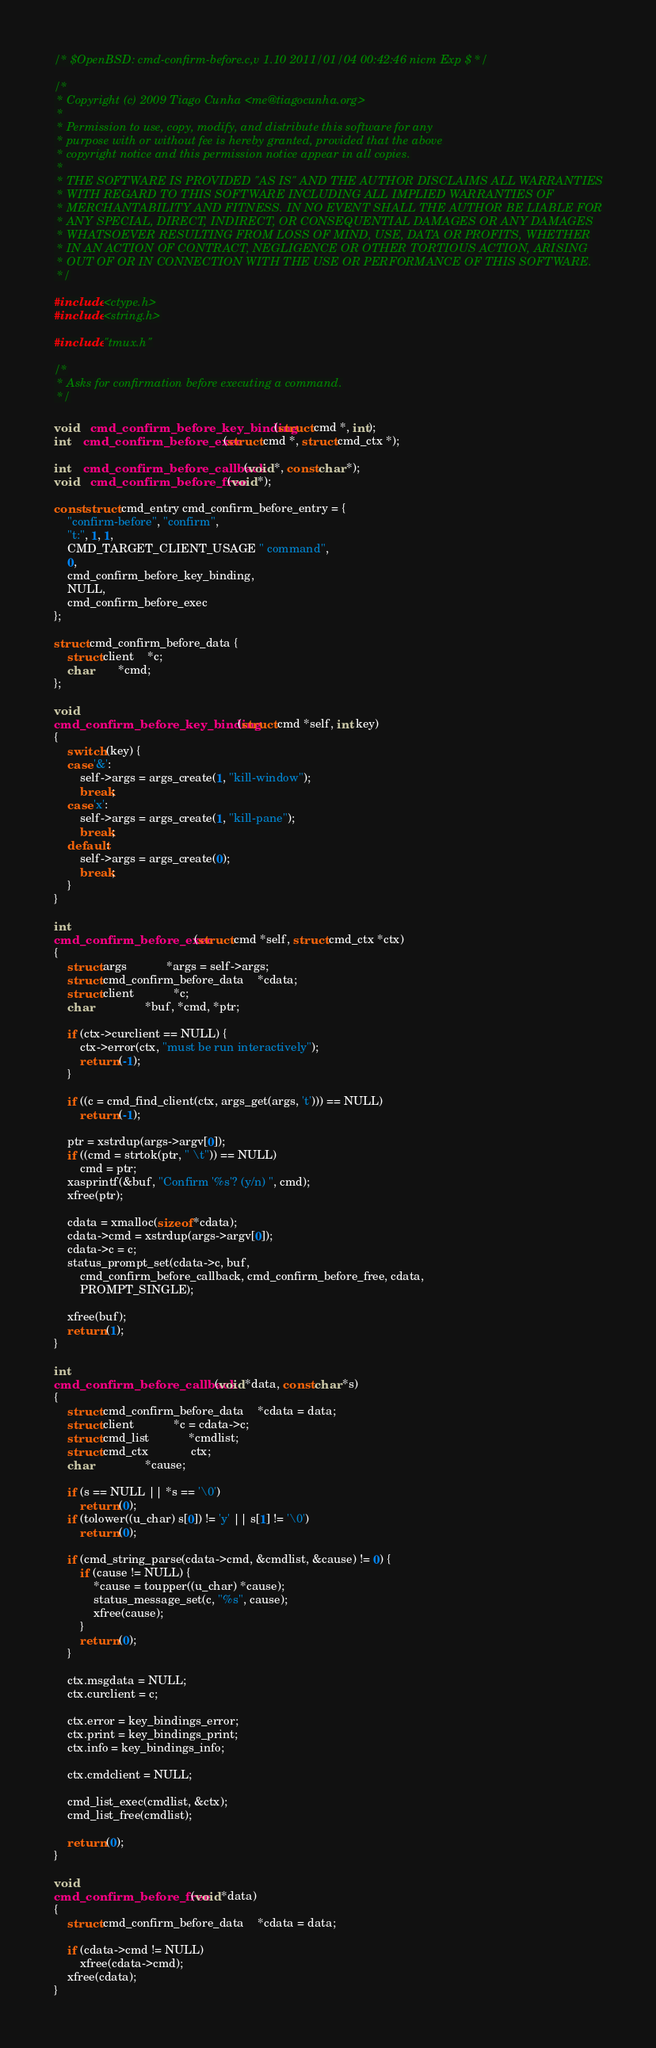Convert code to text. <code><loc_0><loc_0><loc_500><loc_500><_C_>/* $OpenBSD: cmd-confirm-before.c,v 1.10 2011/01/04 00:42:46 nicm Exp $ */

/*
 * Copyright (c) 2009 Tiago Cunha <me@tiagocunha.org>
 *
 * Permission to use, copy, modify, and distribute this software for any
 * purpose with or without fee is hereby granted, provided that the above
 * copyright notice and this permission notice appear in all copies.
 *
 * THE SOFTWARE IS PROVIDED "AS IS" AND THE AUTHOR DISCLAIMS ALL WARRANTIES
 * WITH REGARD TO THIS SOFTWARE INCLUDING ALL IMPLIED WARRANTIES OF
 * MERCHANTABILITY AND FITNESS. IN NO EVENT SHALL THE AUTHOR BE LIABLE FOR
 * ANY SPECIAL, DIRECT, INDIRECT, OR CONSEQUENTIAL DAMAGES OR ANY DAMAGES
 * WHATSOEVER RESULTING FROM LOSS OF MIND, USE, DATA OR PROFITS, WHETHER
 * IN AN ACTION OF CONTRACT, NEGLIGENCE OR OTHER TORTIOUS ACTION, ARISING
 * OUT OF OR IN CONNECTION WITH THE USE OR PERFORMANCE OF THIS SOFTWARE.
 */

#include <ctype.h>
#include <string.h>

#include "tmux.h"

/*
 * Asks for confirmation before executing a command.
 */

void	cmd_confirm_before_key_binding(struct cmd *, int);
int	cmd_confirm_before_exec(struct cmd *, struct cmd_ctx *);

int	cmd_confirm_before_callback(void *, const char *);
void	cmd_confirm_before_free(void *);

const struct cmd_entry cmd_confirm_before_entry = {
	"confirm-before", "confirm",
	"t:", 1, 1,
	CMD_TARGET_CLIENT_USAGE " command",
	0,
	cmd_confirm_before_key_binding,
	NULL,
	cmd_confirm_before_exec
};

struct cmd_confirm_before_data {
	struct client	*c;
	char		*cmd;
};

void
cmd_confirm_before_key_binding(struct cmd *self, int key)
{
	switch (key) {
	case '&':
		self->args = args_create(1, "kill-window");
		break;
	case 'x':
		self->args = args_create(1, "kill-pane");
		break;
	default:
		self->args = args_create(0);
		break;
	}
}

int
cmd_confirm_before_exec(struct cmd *self, struct cmd_ctx *ctx)
{
	struct args			*args = self->args;
	struct cmd_confirm_before_data	*cdata;
	struct client			*c;
	char				*buf, *cmd, *ptr;

	if (ctx->curclient == NULL) {
		ctx->error(ctx, "must be run interactively");
		return (-1);
	}

	if ((c = cmd_find_client(ctx, args_get(args, 't'))) == NULL)
		return (-1);

	ptr = xstrdup(args->argv[0]);
	if ((cmd = strtok(ptr, " \t")) == NULL)
		cmd = ptr;
	xasprintf(&buf, "Confirm '%s'? (y/n) ", cmd);
	xfree(ptr);

	cdata = xmalloc(sizeof *cdata);
	cdata->cmd = xstrdup(args->argv[0]);
	cdata->c = c;
	status_prompt_set(cdata->c, buf,
	    cmd_confirm_before_callback, cmd_confirm_before_free, cdata,
	    PROMPT_SINGLE);

	xfree(buf);
	return (1);
}

int
cmd_confirm_before_callback(void *data, const char *s)
{
	struct cmd_confirm_before_data	*cdata = data;
	struct client			*c = cdata->c;
	struct cmd_list			*cmdlist;
	struct cmd_ctx	 	 	 ctx;
	char				*cause;

	if (s == NULL || *s == '\0')
		return (0);
	if (tolower((u_char) s[0]) != 'y' || s[1] != '\0')
		return (0);

	if (cmd_string_parse(cdata->cmd, &cmdlist, &cause) != 0) {
		if (cause != NULL) {
			*cause = toupper((u_char) *cause);
			status_message_set(c, "%s", cause);
			xfree(cause);
		}
		return (0);
	}

	ctx.msgdata = NULL;
	ctx.curclient = c;

	ctx.error = key_bindings_error;
	ctx.print = key_bindings_print;
	ctx.info = key_bindings_info;

	ctx.cmdclient = NULL;

	cmd_list_exec(cmdlist, &ctx);
	cmd_list_free(cmdlist);

	return (0);
}

void
cmd_confirm_before_free(void *data)
{
	struct cmd_confirm_before_data	*cdata = data;

	if (cdata->cmd != NULL)
		xfree(cdata->cmd);
	xfree(cdata);
}
</code> 